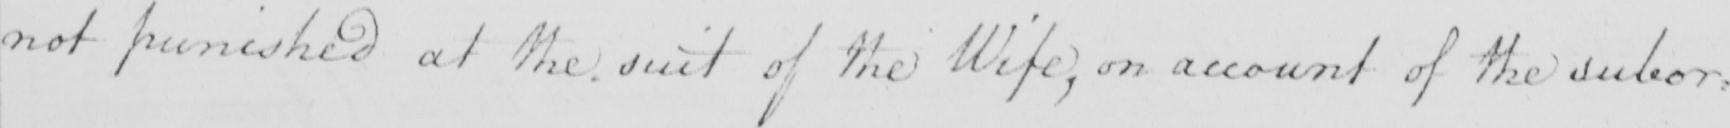What is written in this line of handwriting? not punished at the suit of the Wife , on account of the subor : 